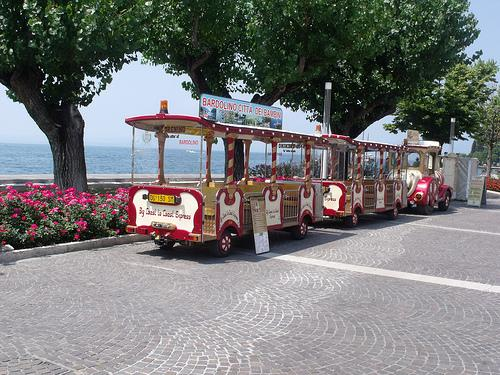What kind of light is on top of the vehicle? There is a small orange light on the top of the vehicle. Mention the types of flowers present near the train. There are pink flower bushes and red flower bushes near the train. Provide an overview of the different types of signs in the image. There is a small sign on the side of the vehicle, a long sign on top of the vehicle, a sign next to the trolley train, and a sign standing by the train. Describe the state of the road or pavement in the image. The stone ground has white lines painted on it and features tan bricks arranged in a pattern. Identify any objects or elements related to the water in the image. There is calm serene water in the background, and flowers and a tree near the water. What is the license plate's color on the vehicle in the image? The license plate is yellow and black. Describe the environment around the train. There are lush green trees behind the train, a tree with green leaves and a brown trunk nearby, red and green bushes, pink flowers, and calm water in the background. Provide a brief description of the scene in the image. There is a red and white train car on stone ground with several vehicles parked on the side, trees and bushes around, and serene water in the background. What color is the trolley train and what is its prominent feature? The trolley train is red and white, and it has a sign on top written in another language. How many total vehicles can be seen in the image? There are several vehicles parked on the side and a trolley train, so there could be at least 3-4 vehicles visible. 